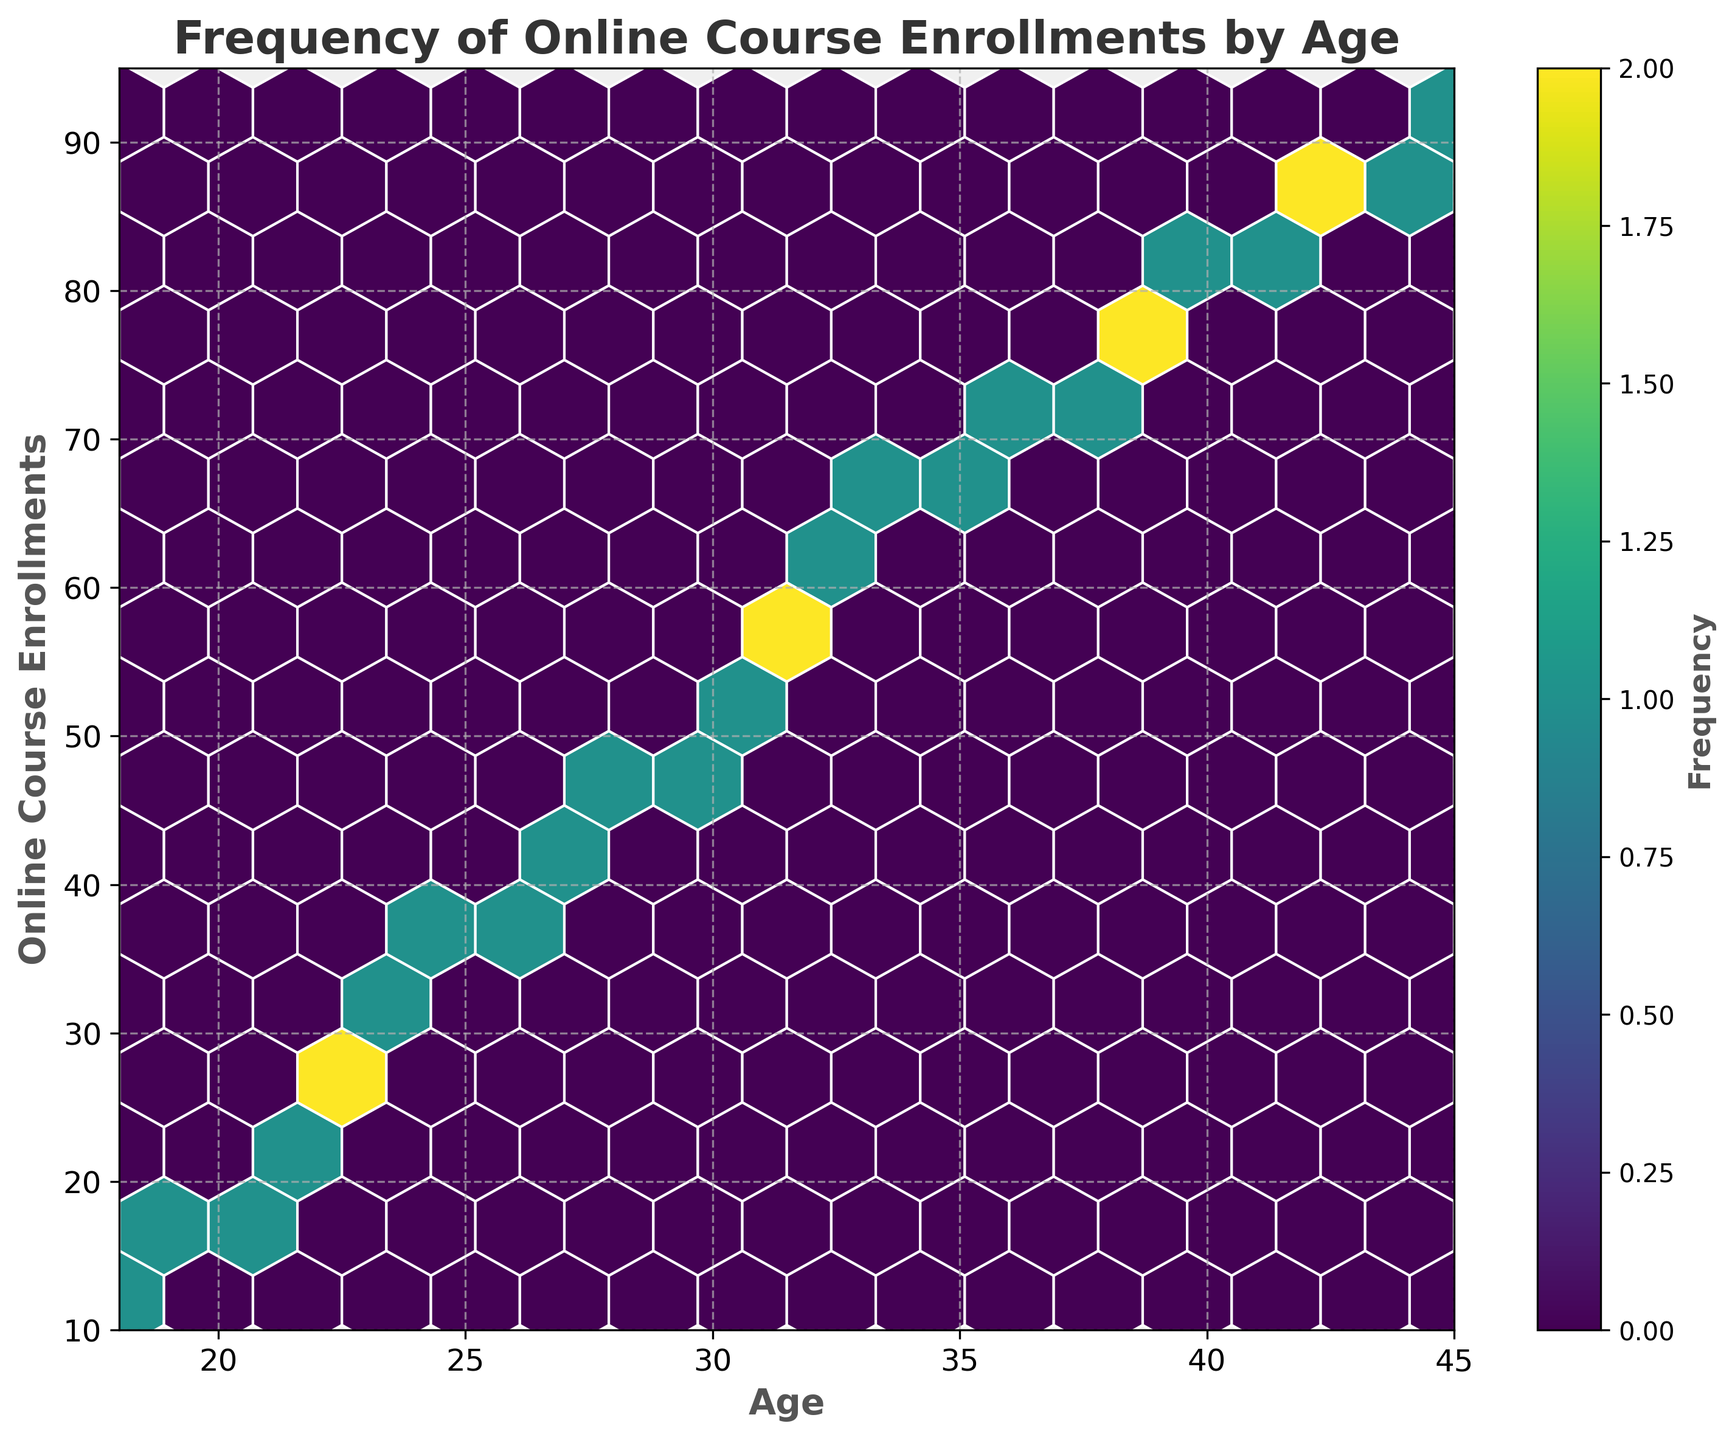What is the title of the plot? Look at the text at the top of the plot. It is written in bold and large font to describe what the plot is about.
Answer: Frequency of Online Course Enrollments by Age What color scheme is used in the hexbin plot? Observe the overall coloring of the plot and legend (color bar). In a hexbin plot, the color scheme helps show the frequency.
Answer: Viridis What are the axes labels? Check the text labels on the horizontal and vertical axes. They typically indicate what the axes represent.
Answer: Age and Online Course Enrollments How many bins appear to have the highest frequency? In a hexbin plot, the bins with the highest frequency are the brightest or most intense in color according to the color bar. Count the number of the most intense bins.
Answer: One What is the range of ages plotted on the x-axis? Look at the numbers on the bottom horizontal axis to identify the starting and ending values.
Answer: 18 to 45 At what age is the frequency of online course enrollments the highest? Find the age corresponding to the bin with the highest intensity (most frequent occurrences).
Answer: 45 Is there a general trend in online course enrollments as age increases? Observe the overall pattern of data points in the plot. Notice if there is an upward, downward, or random trend.
Answer: Increasing trend Between ages 30 and 35, how do the enrollment frequencies compare? Look at the bins between ages 30 and 35 and compare their color intensities.
Answer: Higher towards 35 What does the color bar represent in this hexbin plot? The color bar provides a key to interpret the colors in the plot. It indicates what the colors (frequency shades) signify.
Answer: Frequency Overall, which age group (in a 5-year range) shows the highest concentration of enrollments? Analyze groups of ages in 5-year increments. Check which group has the most bins with higher color intensity.
Answer: 40-45 